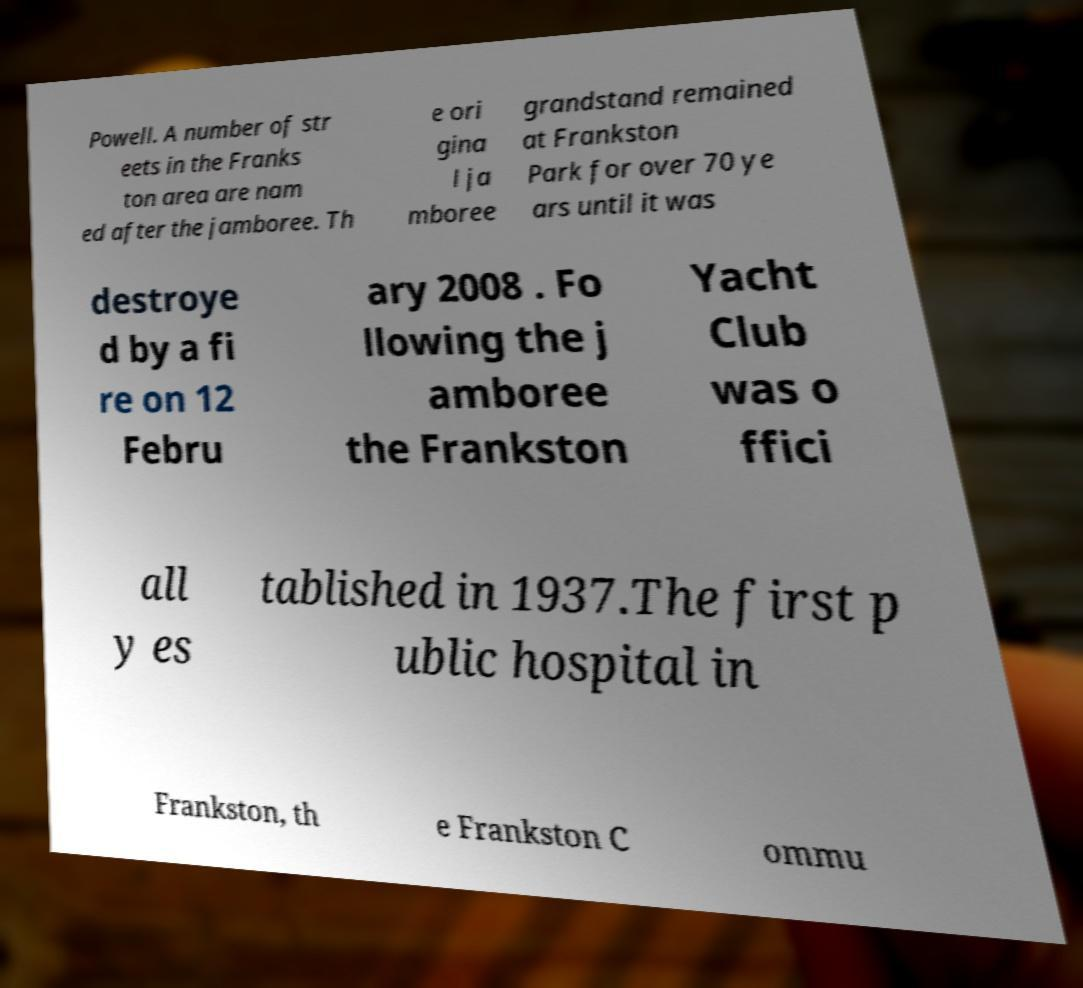For documentation purposes, I need the text within this image transcribed. Could you provide that? Powell. A number of str eets in the Franks ton area are nam ed after the jamboree. Th e ori gina l ja mboree grandstand remained at Frankston Park for over 70 ye ars until it was destroye d by a fi re on 12 Febru ary 2008 . Fo llowing the j amboree the Frankston Yacht Club was o ffici all y es tablished in 1937.The first p ublic hospital in Frankston, th e Frankston C ommu 